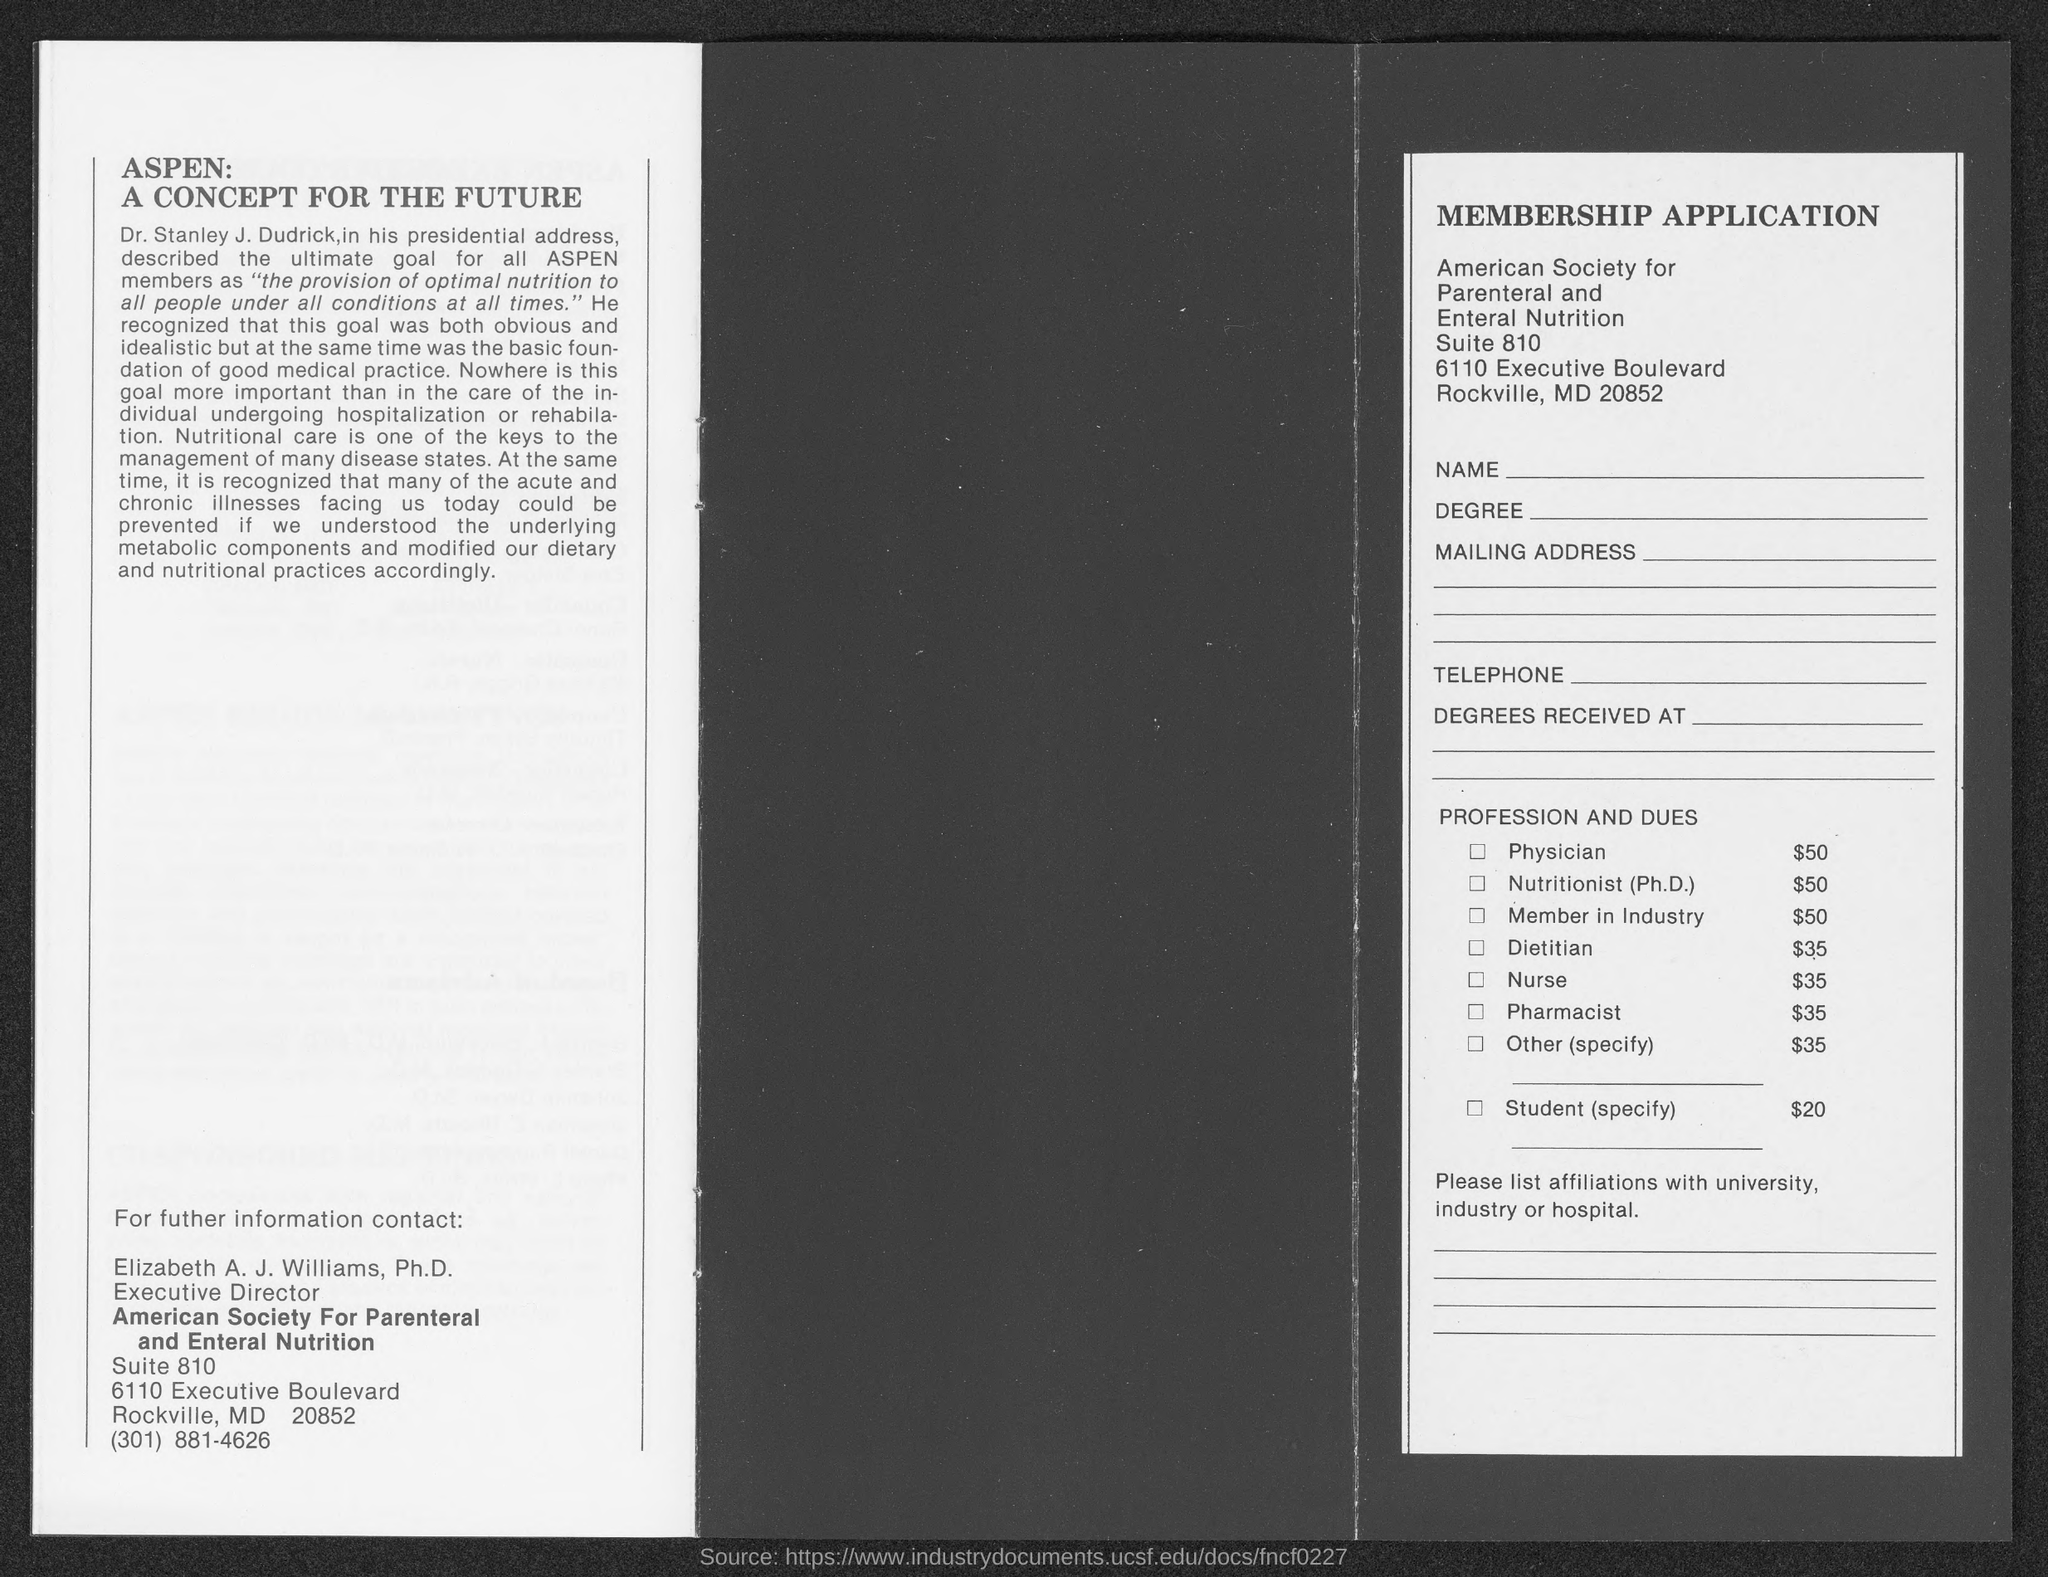What is the ultimate goal for all ASPEN members?
Your response must be concise. The provision of optimal nutrition to all people under all conditions at all times. What is the key to manage many disease states?
Your answer should be compact. Nutritional care. 